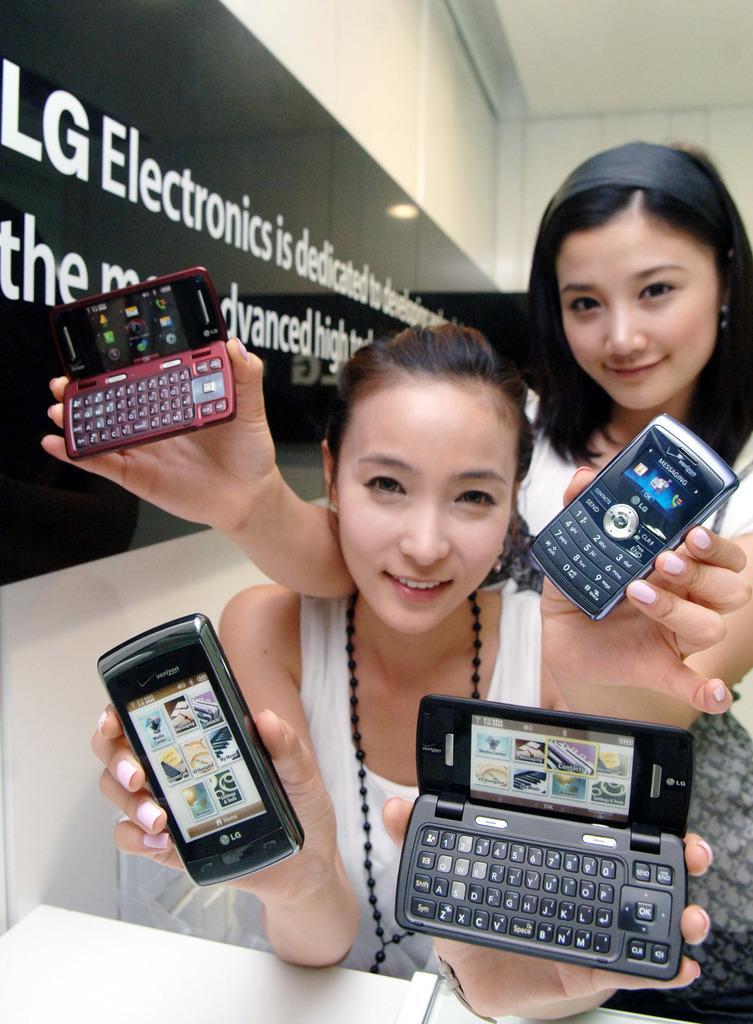Describe this image in one or two sentences. In this picture we can see two woman where they are holding mobiles in their both hands and in background we can see wall, banner. 